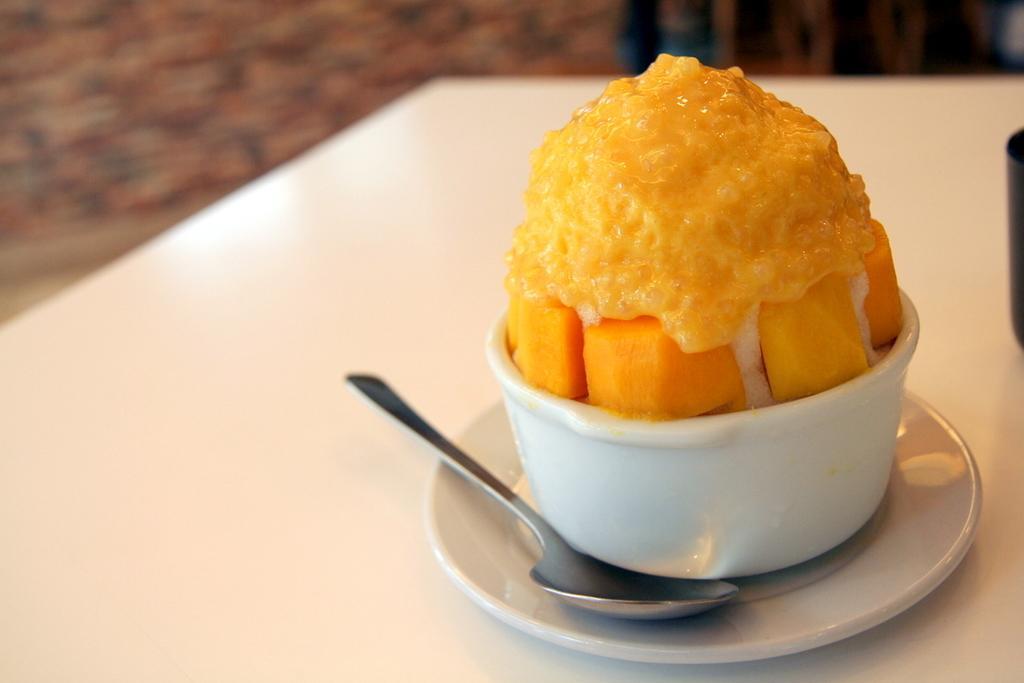Could you give a brief overview of what you see in this image? In this image I can see the food item in the bowl. I can also see a spoon and a plate on the table. 